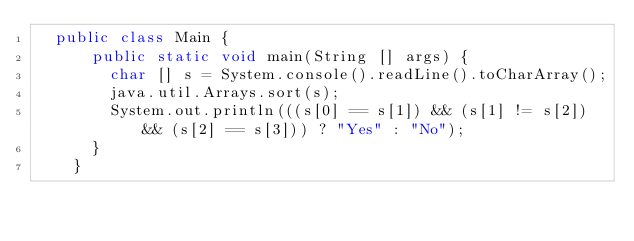<code> <loc_0><loc_0><loc_500><loc_500><_Java_>  public class Main {
      public static void main(String [] args) {
        char [] s = System.console().readLine().toCharArray();
        java.util.Arrays.sort(s);
        System.out.println(((s[0] == s[1]) && (s[1] != s[2]) && (s[2] == s[3])) ? "Yes" : "No");
      }
    }</code> 